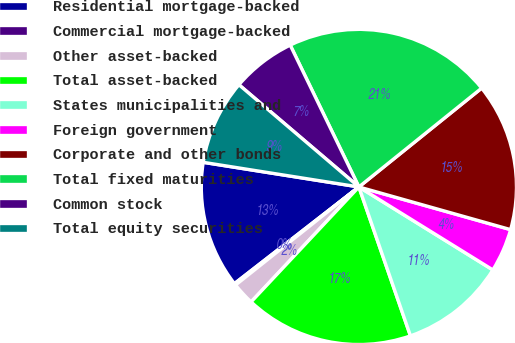Convert chart to OTSL. <chart><loc_0><loc_0><loc_500><loc_500><pie_chart><fcel>Residential mortgage-backed<fcel>Commercial mortgage-backed<fcel>Other asset-backed<fcel>Total asset-backed<fcel>States municipalities and<fcel>Foreign government<fcel>Corporate and other bonds<fcel>Total fixed maturities<fcel>Common stock<fcel>Total equity securities<nl><fcel>13.01%<fcel>0.18%<fcel>2.32%<fcel>17.29%<fcel>10.87%<fcel>4.46%<fcel>15.15%<fcel>21.39%<fcel>6.59%<fcel>8.73%<nl></chart> 